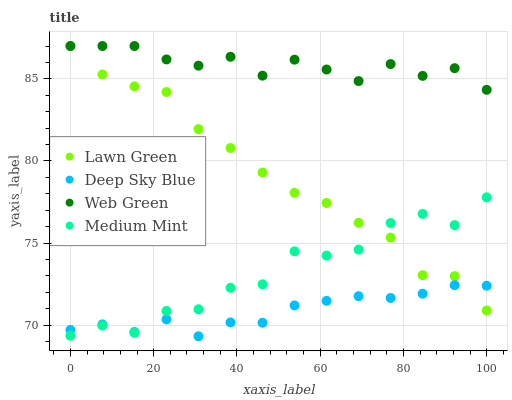Does Deep Sky Blue have the minimum area under the curve?
Answer yes or no. Yes. Does Web Green have the maximum area under the curve?
Answer yes or no. Yes. Does Lawn Green have the minimum area under the curve?
Answer yes or no. No. Does Lawn Green have the maximum area under the curve?
Answer yes or no. No. Is Deep Sky Blue the smoothest?
Answer yes or no. Yes. Is Medium Mint the roughest?
Answer yes or no. Yes. Is Lawn Green the smoothest?
Answer yes or no. No. Is Lawn Green the roughest?
Answer yes or no. No. Does Deep Sky Blue have the lowest value?
Answer yes or no. Yes. Does Lawn Green have the lowest value?
Answer yes or no. No. Does Web Green have the highest value?
Answer yes or no. Yes. Does Deep Sky Blue have the highest value?
Answer yes or no. No. Is Medium Mint less than Web Green?
Answer yes or no. Yes. Is Web Green greater than Medium Mint?
Answer yes or no. Yes. Does Medium Mint intersect Deep Sky Blue?
Answer yes or no. Yes. Is Medium Mint less than Deep Sky Blue?
Answer yes or no. No. Is Medium Mint greater than Deep Sky Blue?
Answer yes or no. No. Does Medium Mint intersect Web Green?
Answer yes or no. No. 